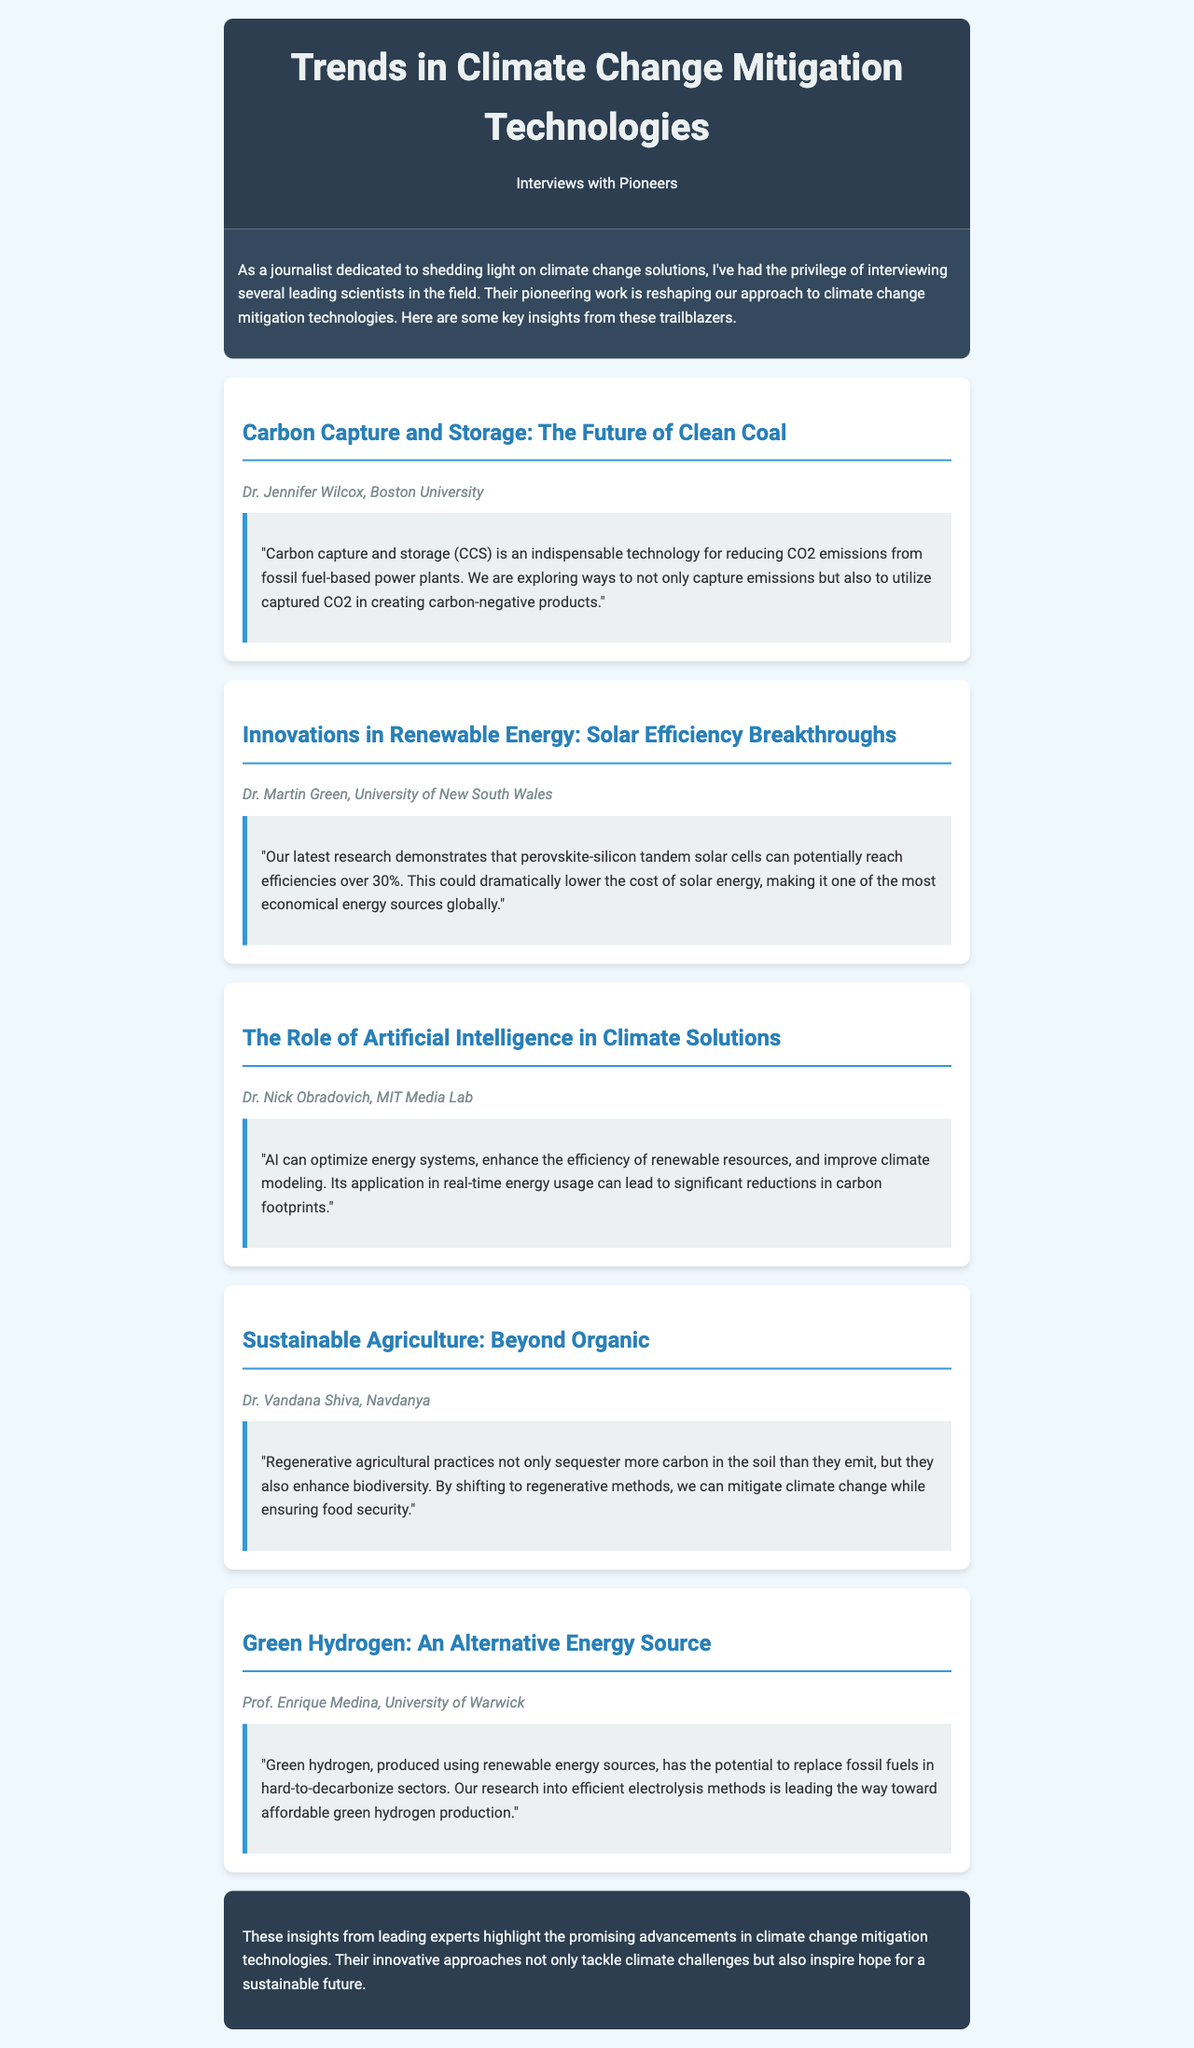what is the title of the newsletter? The title of the newsletter is prominently displayed at the top of the document, indicating its main focus.
Answer: Trends in Climate Change Mitigation Technologies who is the expert associated with carbon capture and storage? The expert who discusses carbon capture and storage is named in the section dedicated to this topic.
Answer: Dr. Jennifer Wilcox what breakthrough is mentioned in solar energy research? The breakthrough in solar energy is highlighted in the insights provided by the respective expert, pointing to a significant increase in efficiency.
Answer: Perovskite-silicon tandem solar cells which technology is discussed for its role in climate solutions? The section explains how a certain technology can contribute to optimizing energy systems and improving efficiency.
Answer: Artificial Intelligence what agricultural practice is emphasized by Dr. Vandana Shiva? The specific agricultural practice that Dr. Vandana Shiva focuses on is identified in her insights regarding sustainability.
Answer: Regenerative agricultural practices what is the potential production method for green hydrogen mentioned? The newsletter specifies the production method that makes green hydrogen an attractive alternative energy source.
Answer: Efficient electrolysis methods 